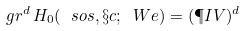Convert formula to latex. <formula><loc_0><loc_0><loc_500><loc_500>\ g r ^ { d } \, H _ { 0 } ( \ s o s , \S c ; \ W e ) = ( \P I V ) ^ { d }</formula> 